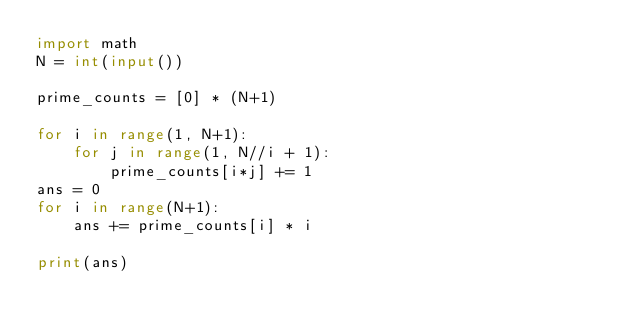<code> <loc_0><loc_0><loc_500><loc_500><_Python_>import math
N = int(input())

prime_counts = [0] * (N+1)

for i in range(1, N+1):
    for j in range(1, N//i + 1):
        prime_counts[i*j] += 1
ans = 0
for i in range(N+1):
    ans += prime_counts[i] * i

print(ans)
    
</code> 